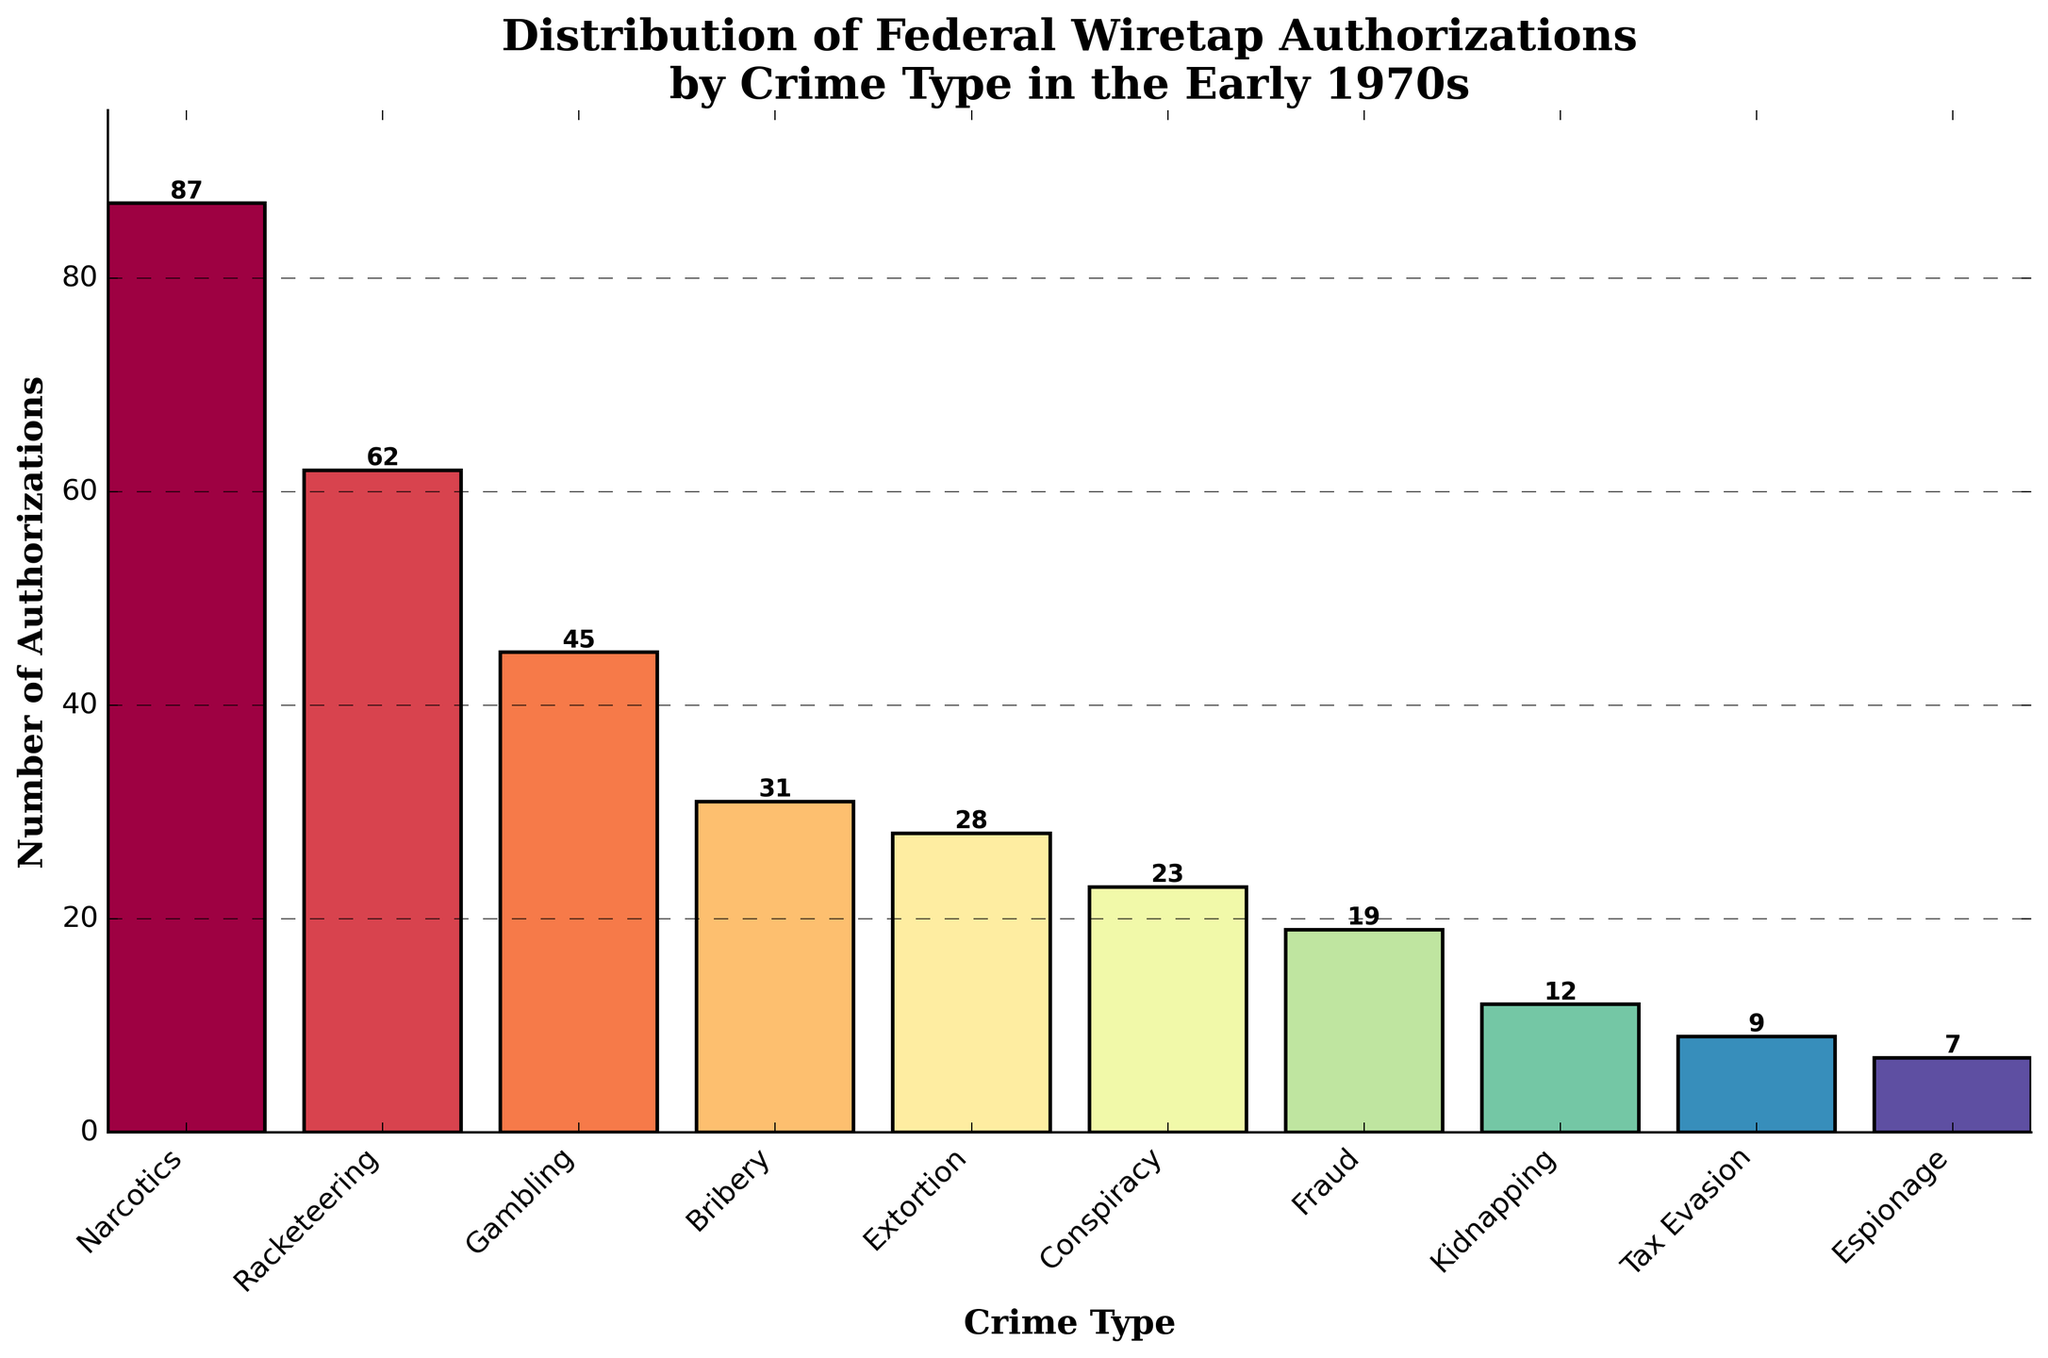What's the most common crime type for federal wiretap authorizations in the early 1970s? By looking at the bar chart, the tallest bar represents the most common crime type. The tallest bar is for "Narcotics" with 87 authorizations.
Answer: Narcotics Which crime types have fewer than 20 federal wiretap authorizations? Any bar shorter than the one representing "Fraud," which has 19 authorizations, corresponds to fewer than 20 authorizations. Specifically, "Kidnapping" (12), "Tax Evasion" (9), and "Espionage" (7) fall into this category.
Answer: Kidnapping, Tax Evasion, Espionage What is the difference in the number of authorizations between Narcotics and Gambling? The number of authorizations for Narcotics is 87, and for Gambling, it is 45. The difference is 87 - 45 = 42.
Answer: 42 How many total wiretap authorizations were made for Extortion and Bribery combined? The bar for Extortion shows 28 authorizations, and for Bribery, it shows 31 authorizations. The total is 28 + 31 = 59.
Answer: 59 Compare the number of authorizations for Racketeering and Conspiracy. Which one has more? Racketeering has 62 authorizations and Conspiracy has 23 authorizations. Racketeering has more.
Answer: Racketeering What is the average number of authorizations for the crime types with more than 50 authorizations? The crime types with more than 50 authorizations are Narcotics (87) and Racketeering (62). The average is (87 + 62) / 2 = 74.5.
Answer: 74.5 Are there more authorizations for Bribery or Extortion, and by how many? Bribery has 31 authorizations and Extortion has 28. Bribery has more by 31 - 28 = 3.
Answer: Bribery, 3 What is the total number of federal wiretap authorizations for all crime types listed? The sum of authorizations for all crime types is 87 + 62 + 45 + 31 + 28 + 23 + 19 + 12 + 9 + 7 = 323.
Answer: 323 Which crime type has the second highest number of federal wiretap authorizations? By visually comparing the heights of the bars, the second tallest bar after Narcotics (87) is for Racketeering with 62 authorizations.
Answer: Racketeering What percentage of the total authorizations does Tax Evasion represent? The total authorizations are 323. Tax Evasion has 9 authorizations. The percentage is (9 / 323) * 100 ≈ 2.79%.
Answer: 2.79% 